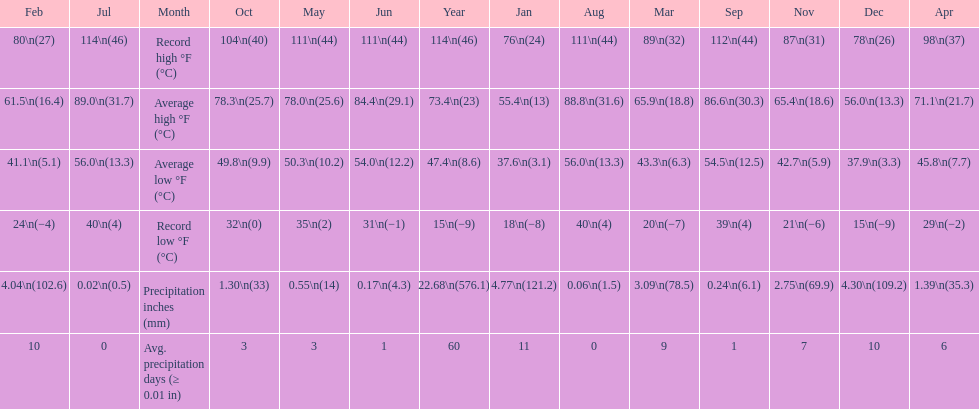Which month had an average high of 89.0 degrees and an average low of 56.0 degrees? July. 